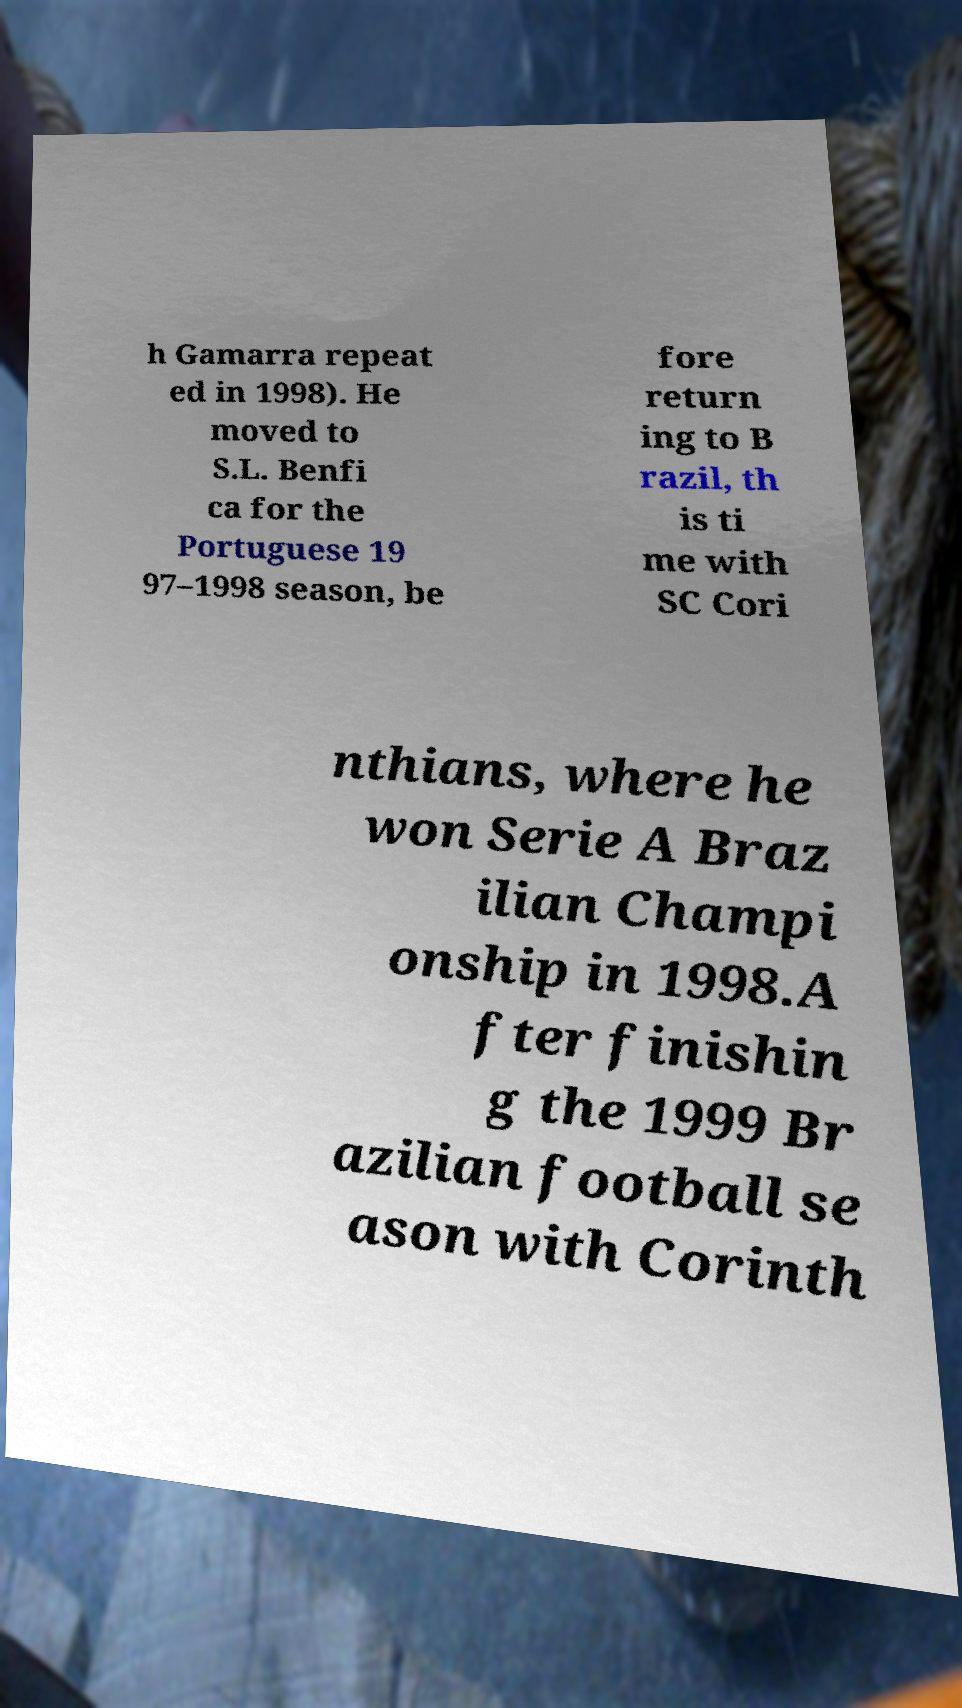There's text embedded in this image that I need extracted. Can you transcribe it verbatim? h Gamarra repeat ed in 1998). He moved to S.L. Benfi ca for the Portuguese 19 97–1998 season, be fore return ing to B razil, th is ti me with SC Cori nthians, where he won Serie A Braz ilian Champi onship in 1998.A fter finishin g the 1999 Br azilian football se ason with Corinth 